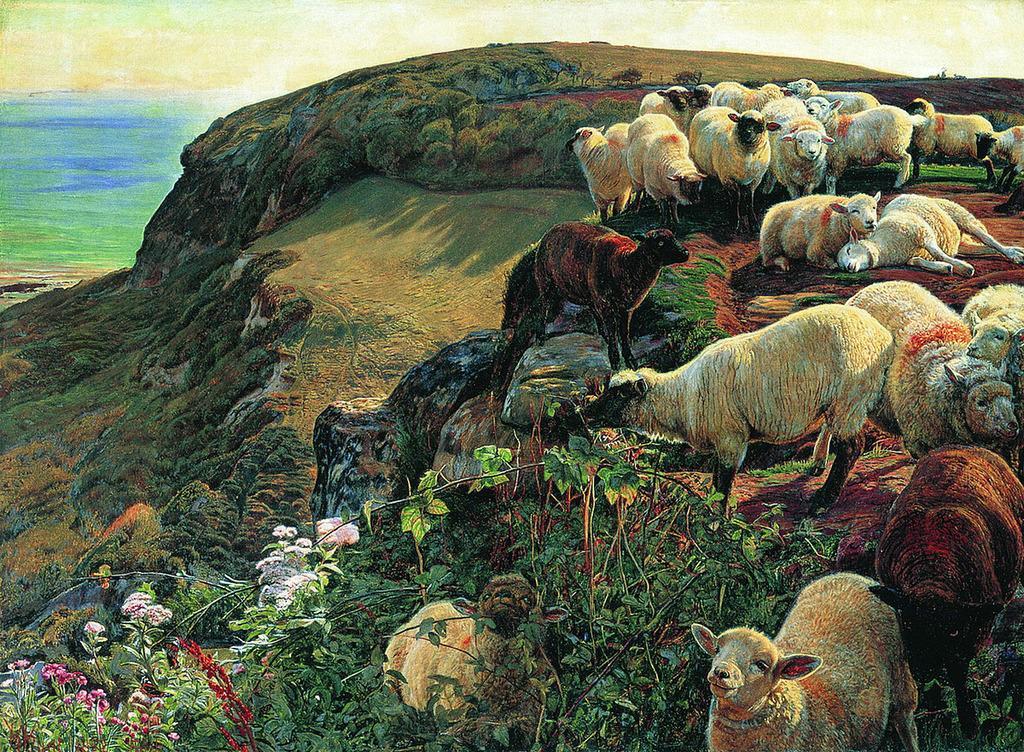How would you summarize this image in a sentence or two? In this image I can see few animals and they are in brown and cream color and I can also see few plants, flowers in pink and white color. In the background I can see the sky. 